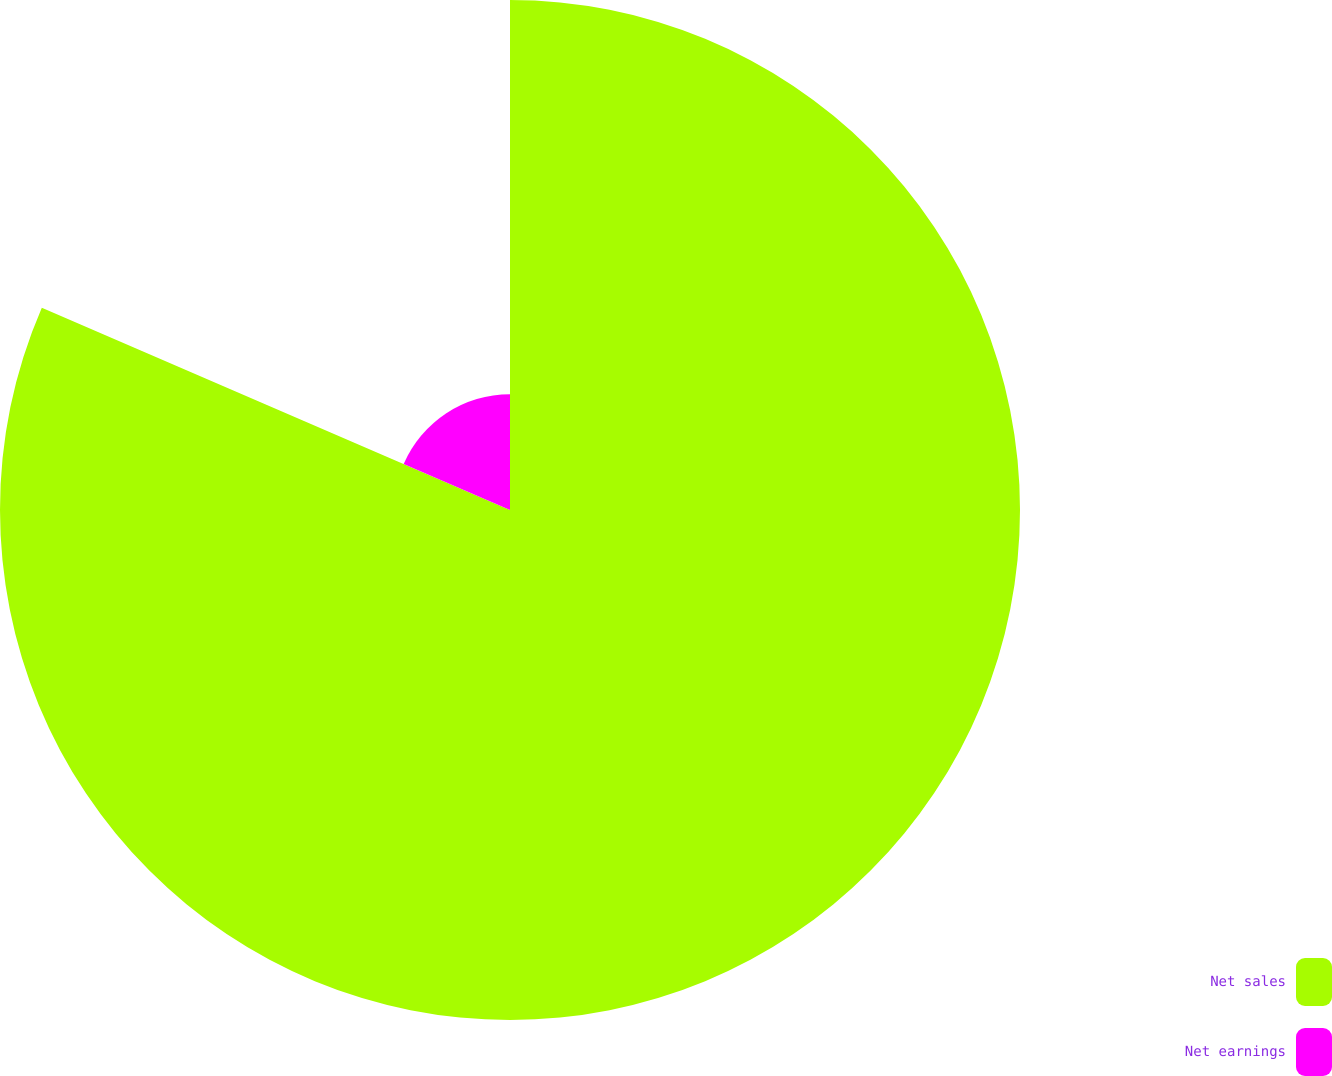Convert chart to OTSL. <chart><loc_0><loc_0><loc_500><loc_500><pie_chart><fcel>Net sales<fcel>Net earnings<nl><fcel>81.49%<fcel>18.51%<nl></chart> 